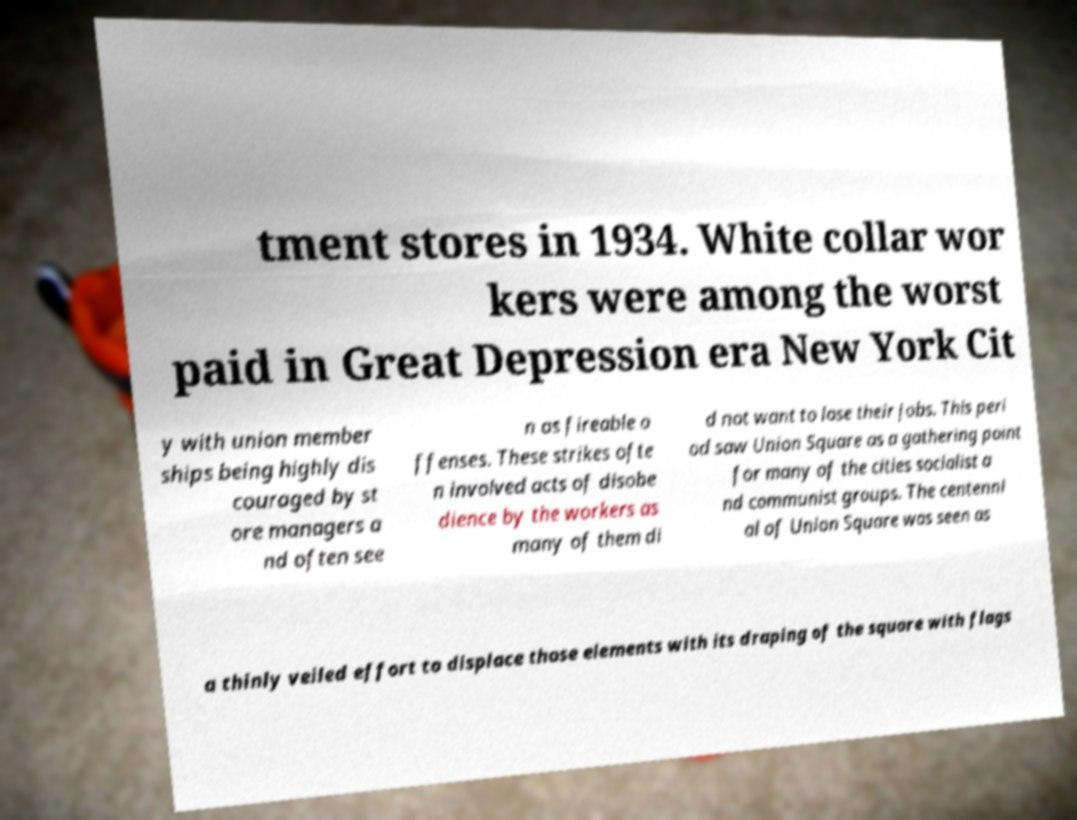Can you read and provide the text displayed in the image?This photo seems to have some interesting text. Can you extract and type it out for me? tment stores in 1934. White collar wor kers were among the worst paid in Great Depression era New York Cit y with union member ships being highly dis couraged by st ore managers a nd often see n as fireable o ffenses. These strikes ofte n involved acts of disobe dience by the workers as many of them di d not want to lose their jobs. This peri od saw Union Square as a gathering point for many of the cities socialist a nd communist groups. The centenni al of Union Square was seen as a thinly veiled effort to displace those elements with its draping of the square with flags 